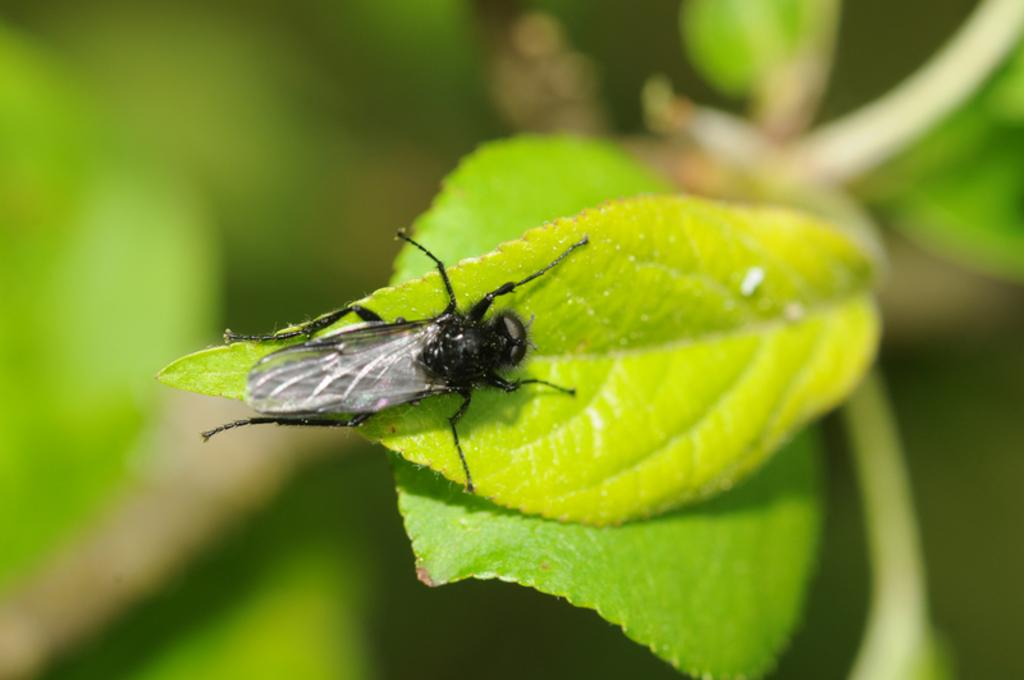What is present on the green leaf in the image? There is an insect on a green leaf in the image. Can you describe the background of the image? The background of the image is blurred. What type of copper material can be seen in the image? There is no copper material present in the image. What store is visible in the background of the image? There is no store visible in the image, as the background is blurred. 